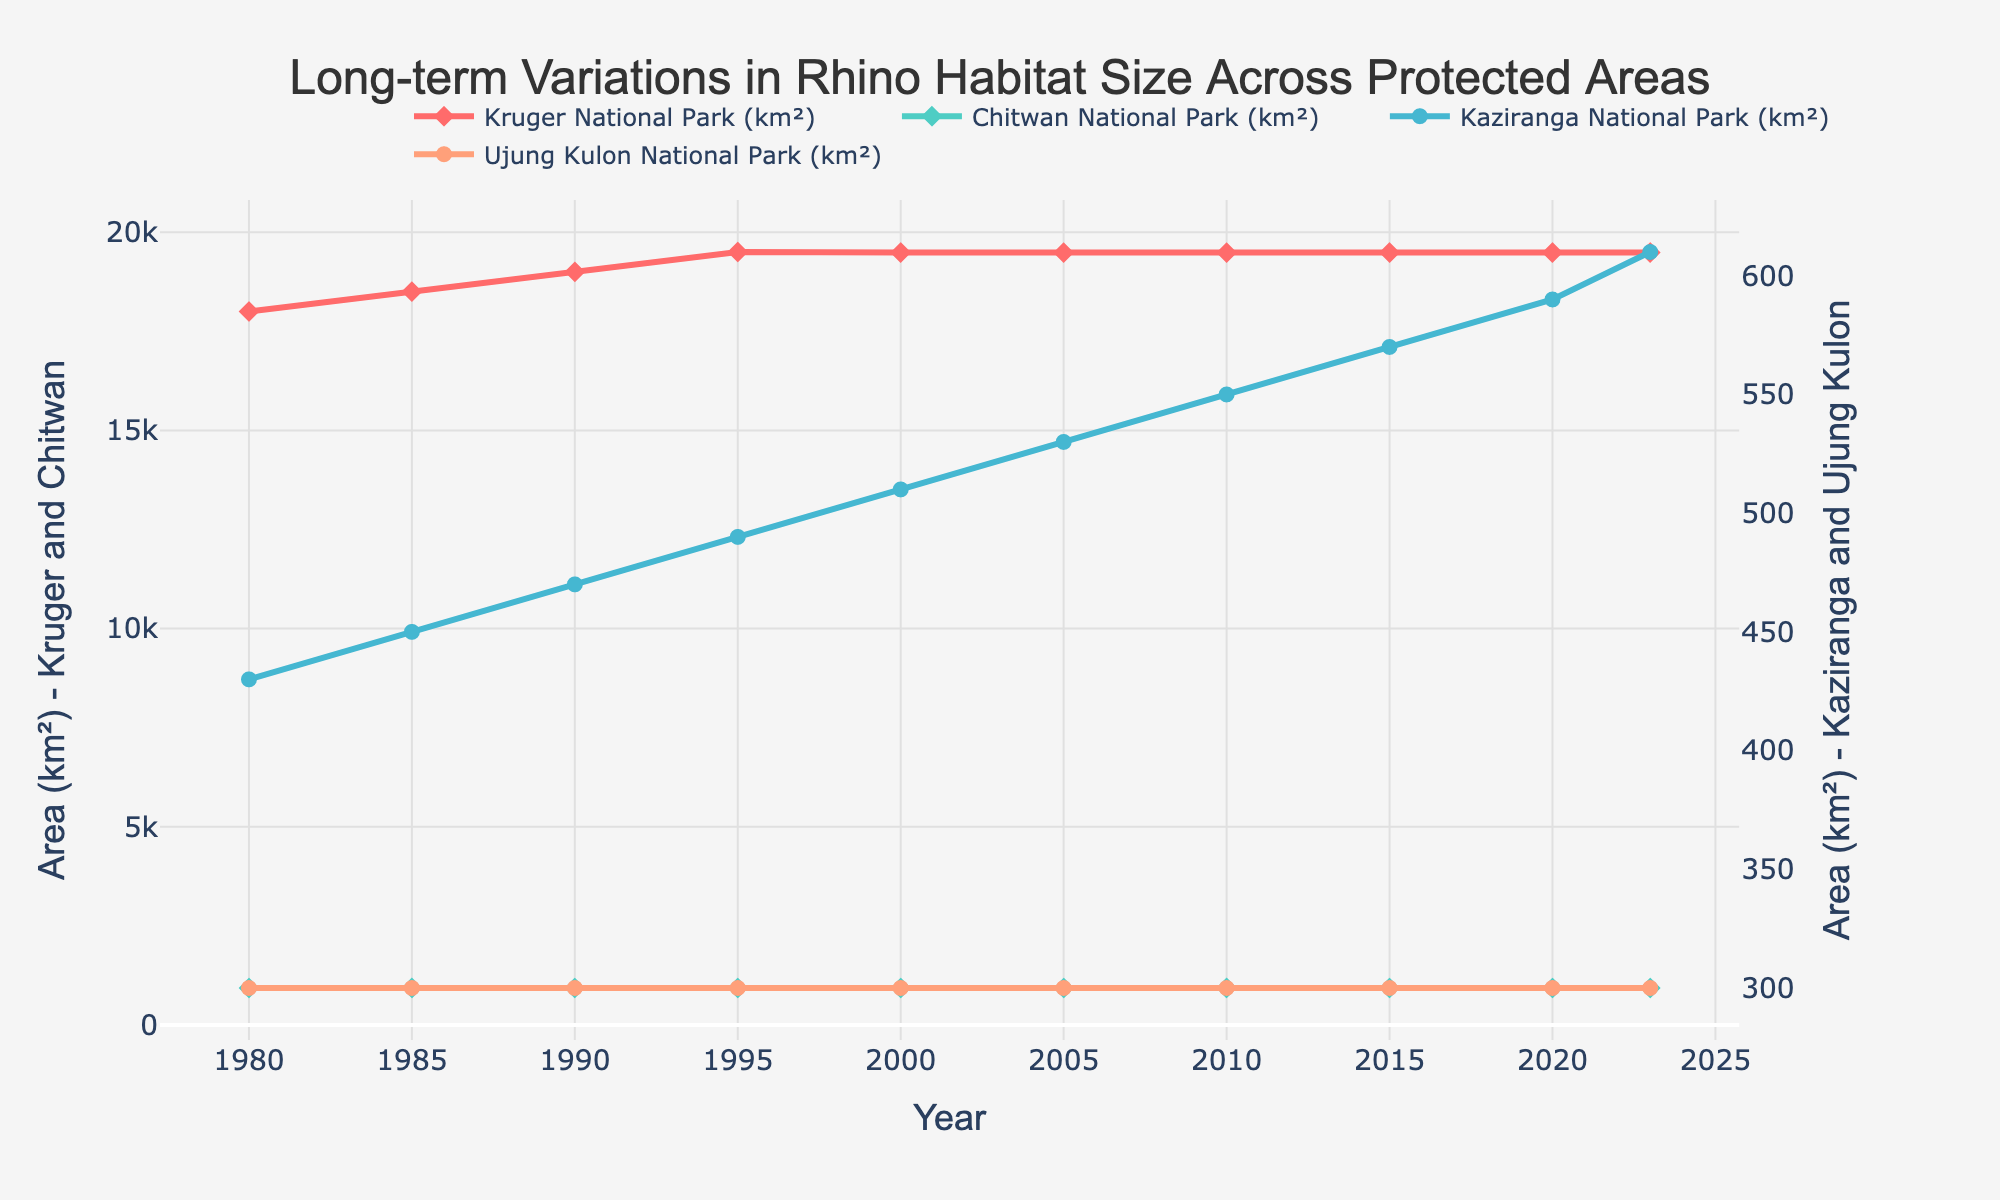what is the maximum increase in area for Kruger National Park between two consecutive measurements? First, observe the values of Kruger National Park at each time point. The increases between consecutive measurements are: 18500 - 18000 = 500 km² (1980-1985), 19000 - 18500 = 500 km² (1985-1990), 19500 - 19000 = 500 km² (1990-1995). From 1995 the changes are smaller or zero. Thus, the maximum increase is 500 km².
Answer: 500 km² In which year does Kaziranga National Park show the first increase of at least 20 km² compared to the previous measurement? Look for years where the increase between the current and previous measurements for Kaziranga National Park (km²) is at least 20 km². The values go from 430 in 1980 to 450 in 1985 (20 km² increase).
Answer: 1985 What is the average area of all parks in the year 2000? Sum the areas of all parks in 2000 and divide by the number of parks: (19485 + 932 + 510 + 300) / 4 = 21227/4 ≈ 5306.75 km².
Answer: 5306.75 km² How many years show no change in habitat size for Ujung Kulon National Park? Ujung Kulon National Park has the same value (300 km²) across all years from 1980 to 2023. Count the number of years, which is 10.
Answer: 10 Which park shows the most stable habitat size over time? Compare the changes in habitat size for all parks over years. Both Chitwan National Park and Ujung Kulon National Park have no change. Since Chitwan has more data points but still no change over time, choose Chitwan based on stability and reporting duration.
Answer: Chitwan National Park Which year shows the first occurrence where Chitwan National Park has an equal habitat size to Kruger National Park? No year shows Chitwan National Park achieving an equal value to Kruger National Park. Review the values: Chitwan remains 932 km², whereas Kruger starts much higher.
Answer: Never By how much did the habitat size of Kaziranga National Park increase from 1980 to 2023? Calculate the difference: 610 km² (2023) - 430 km² (1980) = 180 km².
Answer: 180 km² Between two specific types of markers, does any park use the same type of marker across all years? Observe Kruger and Chitwan using diamond markers and Kaziranga and Ujung Kulon using circle markers, consistently across years. Thus, yes all parks use their markers consistently.
Answer: Yes 